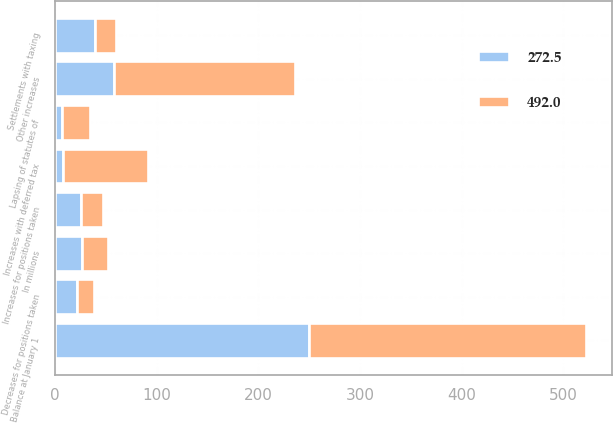Convert chart. <chart><loc_0><loc_0><loc_500><loc_500><stacked_bar_chart><ecel><fcel>In millions<fcel>Balance at January 1<fcel>Decreases for positions taken<fcel>Increases for positions taken<fcel>Increases with deferred tax<fcel>Other increases<fcel>Settlements with taxing<fcel>Lapsing of statutes of<nl><fcel>492<fcel>26<fcel>272.5<fcel>16.4<fcel>21.8<fcel>83.9<fcel>178<fcel>20.8<fcel>27<nl><fcel>272.5<fcel>26<fcel>249.7<fcel>21.8<fcel>25<fcel>7.7<fcel>58.2<fcel>39.5<fcel>6.8<nl></chart> 